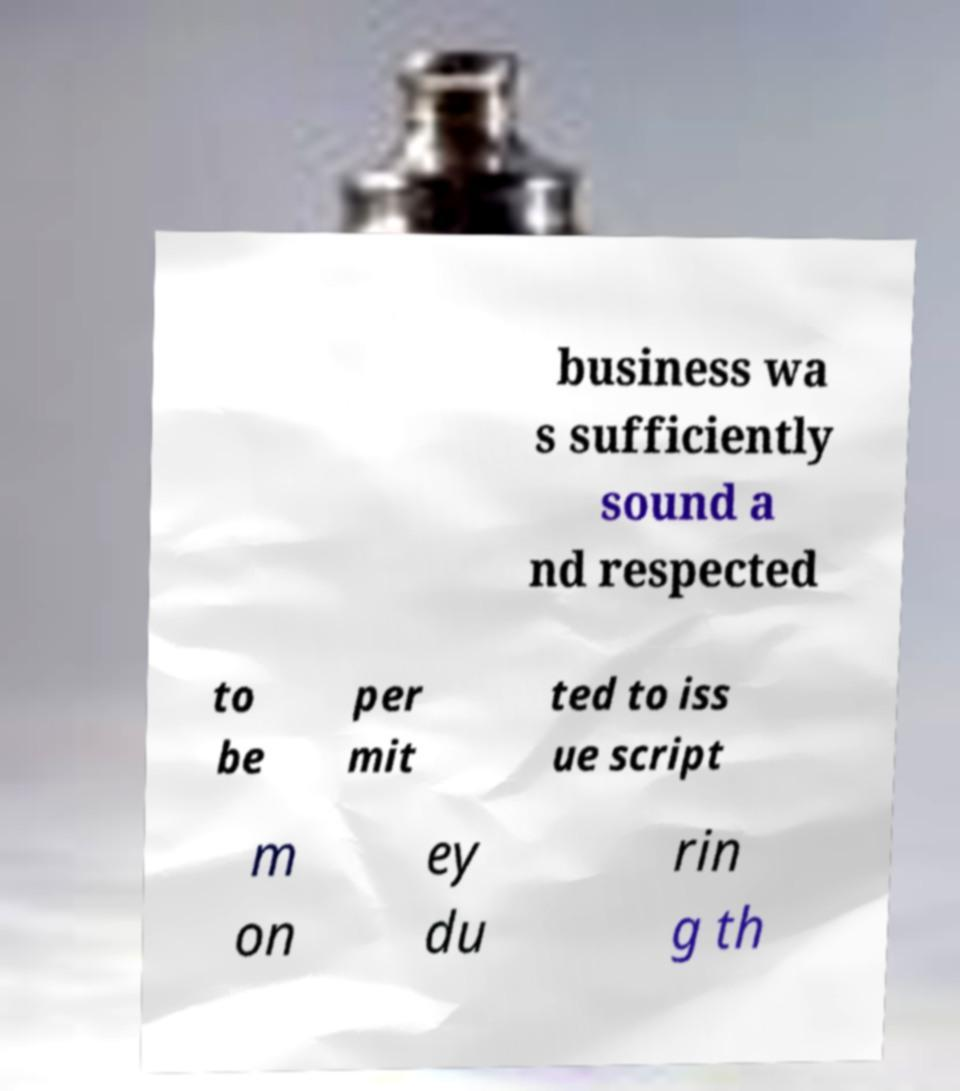What messages or text are displayed in this image? I need them in a readable, typed format. business wa s sufficiently sound a nd respected to be per mit ted to iss ue script m on ey du rin g th 